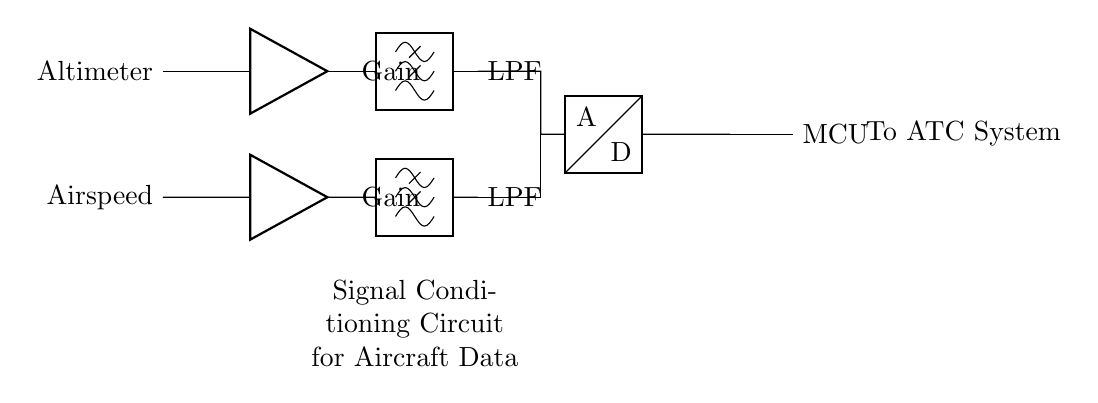What inputs does this circuit process? The circuit processes two inputs: Altimeter and Airspeed, which are labeled on the left side of the diagram.
Answer: Altimeter, Airspeed What type of filters are used in the circuit? The circuit uses low-pass filters (LPF) indicated by the label connected to the output of the amplifiers.
Answer: Low-pass filters How many amplifiers are present in this circuit? There are two amplifiers, one for each input signal (Altimeter and Airspeed), each connected to its corresponding input.
Answer: Two What component converts the filtered analog signals into digital signals? The analog signals are converted into digital signals by the Analog-to-Digital Converter (ADC), which is shown in the lower section of the circuit.
Answer: ADC What is the purpose of the microcontroller in this circuit? The microcontroller (MCU) is responsible for processing the digital signals from the ADC and preparing them for transmission to the ATC System.
Answer: Processing Why are low-pass filters used after the amplifiers? Low-pass filters are used to eliminate high-frequency noise from the amplified signals, ensuring accurate data representation for the ADC.
Answer: To eliminate high-frequency noise 